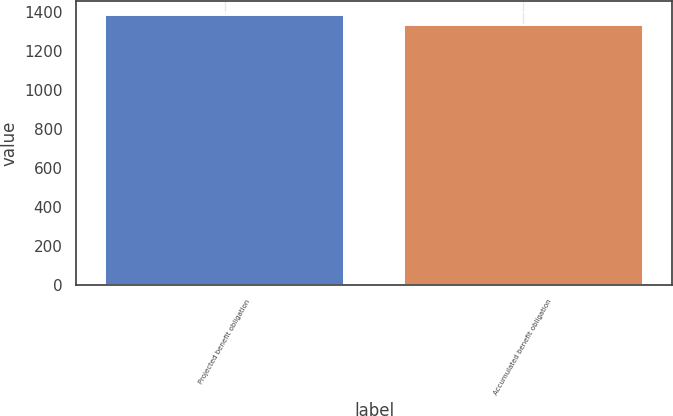Convert chart to OTSL. <chart><loc_0><loc_0><loc_500><loc_500><bar_chart><fcel>Projected benefit obligation<fcel>Accumulated benefit obligation<nl><fcel>1385<fcel>1334.7<nl></chart> 